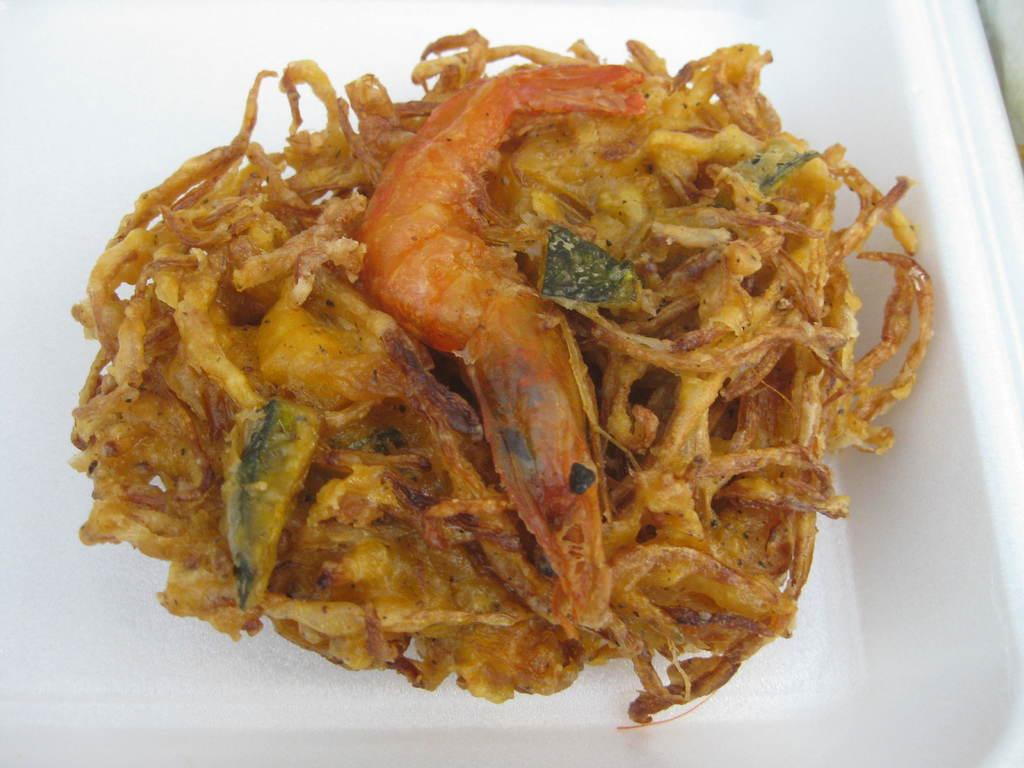What is the main subject of the image? The main subject of the image is a food item. How is the food item presented in the image? The food item is kept in a white bowl. What type of jewel can be seen on the food item in the image? There is no jewel present on the food item in the image. What is the weight of the food item in the image, as measured by a scale? The weight of the food item cannot be determined from the image, as there is no scale present. 